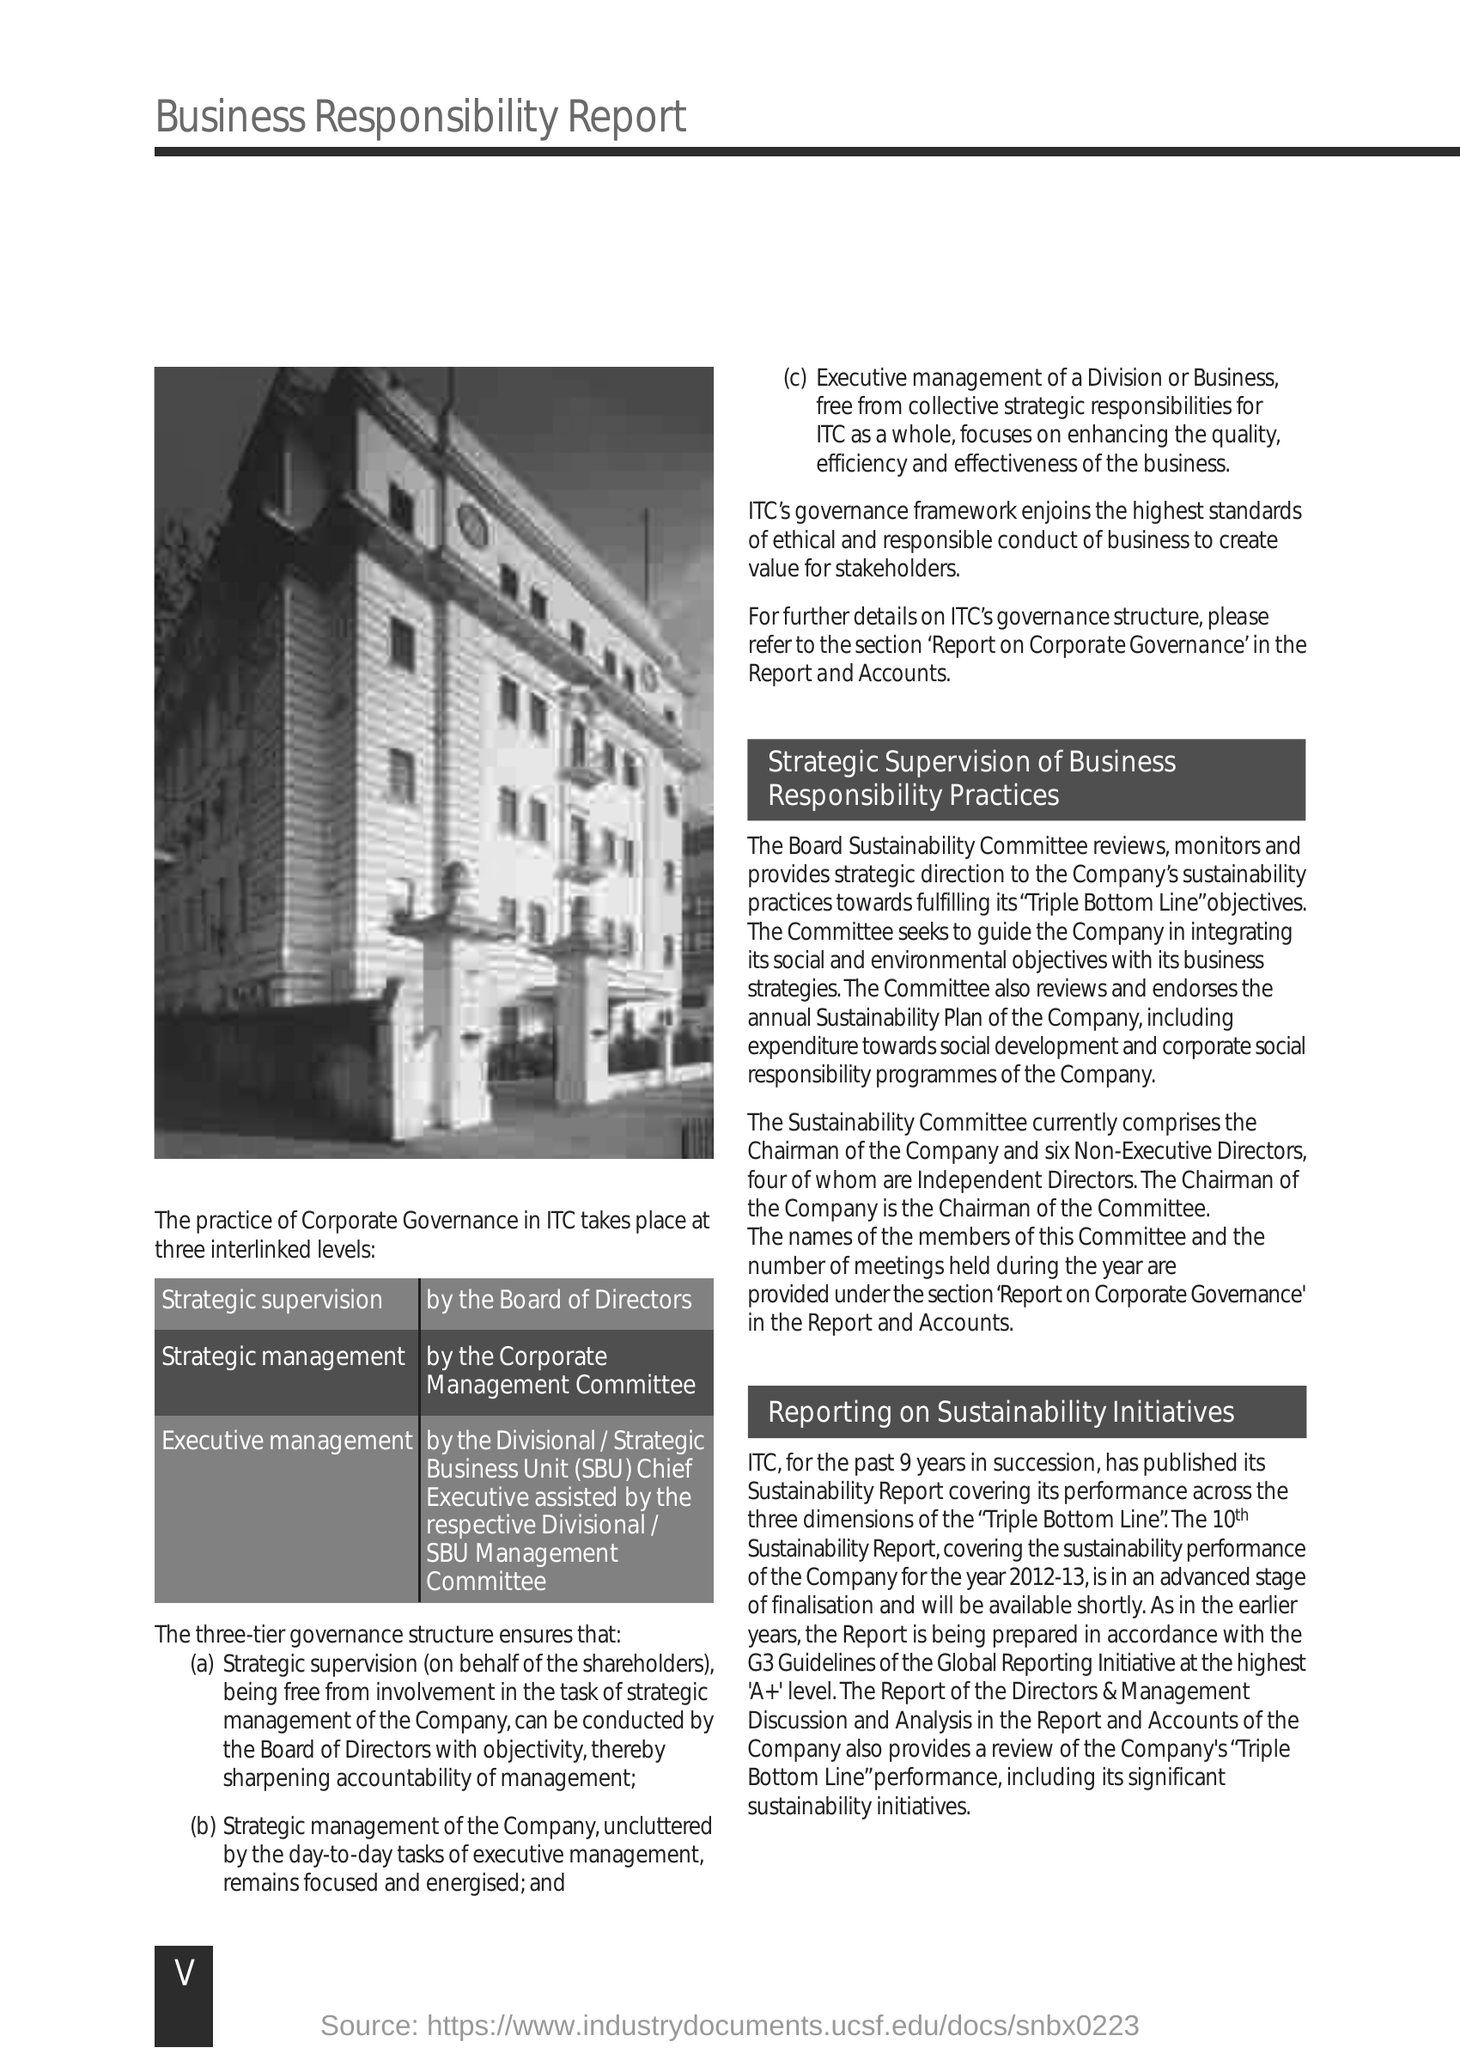Point out several critical features in this image. This is a business responsibility report. The first subheading given in the Report is 'strategic supervision of business responsibility practices'. The Chairman of the Committee is the chairman of the company. The practice of Corporate Governance in ITC occurs at multiple interlinked levels. The practice of corporate governance in ITC involves the third level of executive management. 